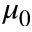<formula> <loc_0><loc_0><loc_500><loc_500>\mu _ { 0 }</formula> 